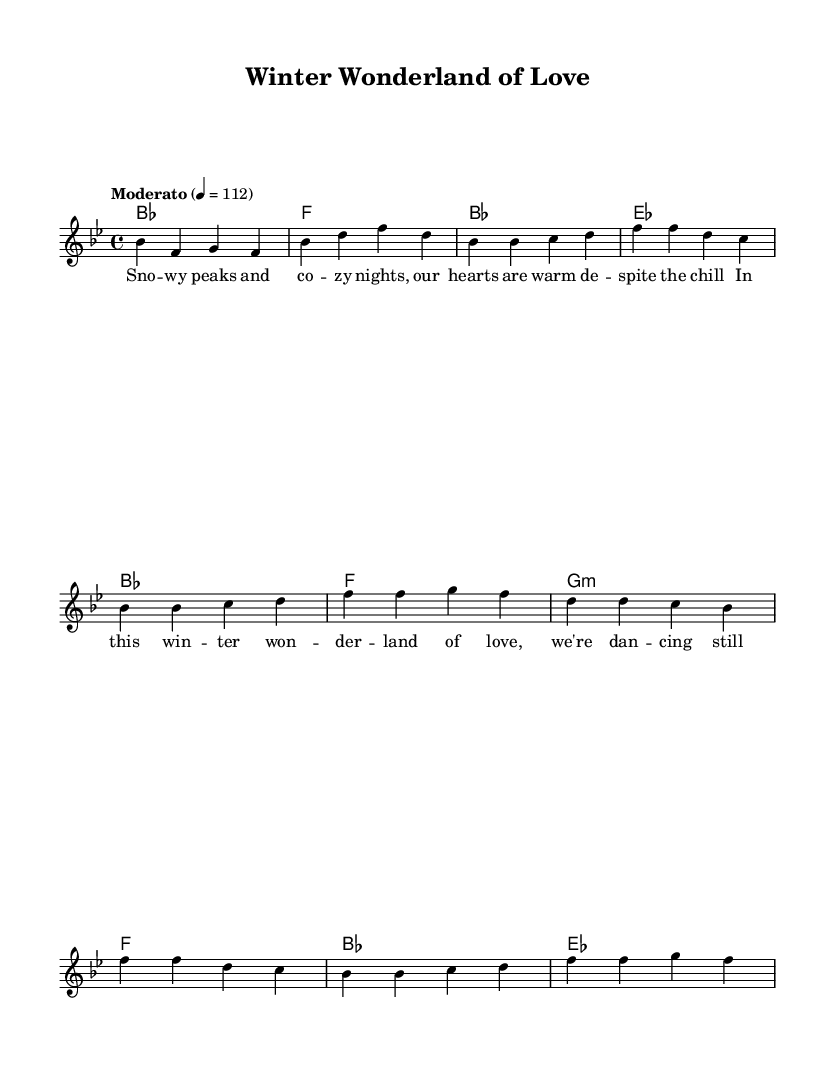What is the key signature of this music? The key signature is indicated at the beginning of the sheet music. In this piece, it shows two flats, which corresponds to B flat major.
Answer: B flat major What is the time signature of this piece? The time signature is located at the beginning of the score, where it is indicated as 4/4, meaning there are four beats in a measure and the quarter note gets one beat.
Answer: 4/4 What is the tempo marking for this piece? The tempo marking is found at the start of the music, where it specifies "Moderato" and a tempo of 112 beats per minute, indicating a moderate pace.
Answer: Moderato 112 What is the first chord in the composition? The first chord is shown in the harmonies section, which indicates it is a B flat major chord played as a whole note.
Answer: B flat How many measures are in the verse section? The verse section consists of the part following the introductory measures. By counting the bars notated, there are 4 measures in the verse section.
Answer: 4 How many times does the chorus repeat during the piece? The chorus is structured based on the lyrics and melodic sections provided. Observing the layout, the chorus appears to repeat 2 times throughout this fragment of the score.
Answer: 2 What lyrical theme is prominent in this music? The lyrical theme talks about winter and love, highlighted in the first line describing snowy peaks and cozy nights, reflecting warmth despite coldness.
Answer: Winter love 